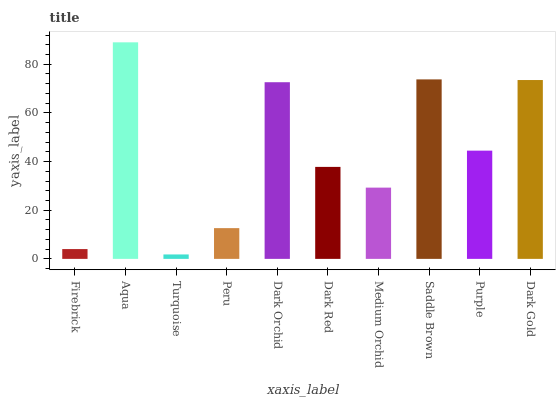Is Turquoise the minimum?
Answer yes or no. Yes. Is Aqua the maximum?
Answer yes or no. Yes. Is Aqua the minimum?
Answer yes or no. No. Is Turquoise the maximum?
Answer yes or no. No. Is Aqua greater than Turquoise?
Answer yes or no. Yes. Is Turquoise less than Aqua?
Answer yes or no. Yes. Is Turquoise greater than Aqua?
Answer yes or no. No. Is Aqua less than Turquoise?
Answer yes or no. No. Is Purple the high median?
Answer yes or no. Yes. Is Dark Red the low median?
Answer yes or no. Yes. Is Medium Orchid the high median?
Answer yes or no. No. Is Medium Orchid the low median?
Answer yes or no. No. 